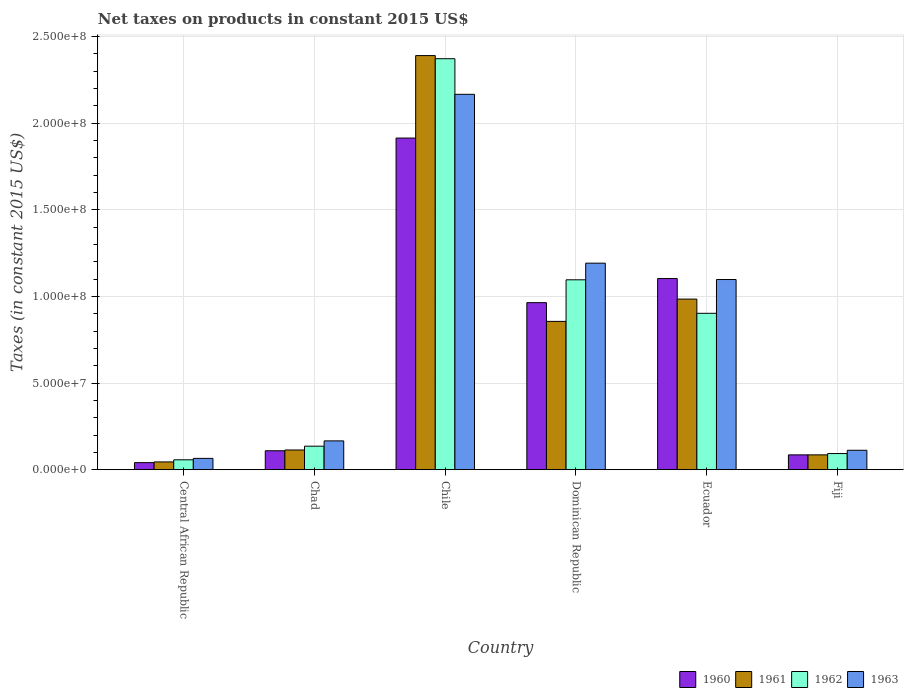Are the number of bars on each tick of the X-axis equal?
Give a very brief answer. Yes. How many bars are there on the 5th tick from the right?
Offer a very short reply. 4. What is the label of the 2nd group of bars from the left?
Provide a succinct answer. Chad. What is the net taxes on products in 1962 in Chad?
Provide a short and direct response. 1.36e+07. Across all countries, what is the maximum net taxes on products in 1963?
Make the answer very short. 2.17e+08. Across all countries, what is the minimum net taxes on products in 1960?
Offer a terse response. 4.08e+06. In which country was the net taxes on products in 1961 minimum?
Your answer should be compact. Central African Republic. What is the total net taxes on products in 1963 in the graph?
Offer a very short reply. 4.80e+08. What is the difference between the net taxes on products in 1962 in Ecuador and that in Fiji?
Provide a succinct answer. 8.09e+07. What is the difference between the net taxes on products in 1961 in Chile and the net taxes on products in 1960 in Fiji?
Your answer should be very brief. 2.30e+08. What is the average net taxes on products in 1961 per country?
Your answer should be very brief. 7.46e+07. What is the difference between the net taxes on products of/in 1960 and net taxes on products of/in 1963 in Chile?
Provide a succinct answer. -2.52e+07. In how many countries, is the net taxes on products in 1963 greater than 20000000 US$?
Ensure brevity in your answer.  3. What is the ratio of the net taxes on products in 1962 in Central African Republic to that in Chile?
Make the answer very short. 0.02. Is the difference between the net taxes on products in 1960 in Chad and Fiji greater than the difference between the net taxes on products in 1963 in Chad and Fiji?
Give a very brief answer. No. What is the difference between the highest and the second highest net taxes on products in 1962?
Offer a terse response. 1.93e+07. What is the difference between the highest and the lowest net taxes on products in 1963?
Offer a very short reply. 2.10e+08. Is the sum of the net taxes on products in 1963 in Dominican Republic and Ecuador greater than the maximum net taxes on products in 1961 across all countries?
Give a very brief answer. No. Are the values on the major ticks of Y-axis written in scientific E-notation?
Give a very brief answer. Yes. Does the graph contain any zero values?
Offer a very short reply. No. What is the title of the graph?
Provide a succinct answer. Net taxes on products in constant 2015 US$. What is the label or title of the Y-axis?
Offer a very short reply. Taxes (in constant 2015 US$). What is the Taxes (in constant 2015 US$) in 1960 in Central African Republic?
Provide a short and direct response. 4.08e+06. What is the Taxes (in constant 2015 US$) of 1961 in Central African Republic?
Make the answer very short. 4.49e+06. What is the Taxes (in constant 2015 US$) in 1962 in Central African Republic?
Your answer should be compact. 5.71e+06. What is the Taxes (in constant 2015 US$) of 1963 in Central African Republic?
Your response must be concise. 6.53e+06. What is the Taxes (in constant 2015 US$) of 1960 in Chad?
Your answer should be very brief. 1.09e+07. What is the Taxes (in constant 2015 US$) of 1961 in Chad?
Ensure brevity in your answer.  1.14e+07. What is the Taxes (in constant 2015 US$) in 1962 in Chad?
Your answer should be very brief. 1.36e+07. What is the Taxes (in constant 2015 US$) in 1963 in Chad?
Provide a succinct answer. 1.66e+07. What is the Taxes (in constant 2015 US$) in 1960 in Chile?
Provide a succinct answer. 1.91e+08. What is the Taxes (in constant 2015 US$) of 1961 in Chile?
Provide a succinct answer. 2.39e+08. What is the Taxes (in constant 2015 US$) in 1962 in Chile?
Make the answer very short. 2.37e+08. What is the Taxes (in constant 2015 US$) of 1963 in Chile?
Provide a short and direct response. 2.17e+08. What is the Taxes (in constant 2015 US$) in 1960 in Dominican Republic?
Provide a short and direct response. 9.64e+07. What is the Taxes (in constant 2015 US$) of 1961 in Dominican Republic?
Your response must be concise. 8.56e+07. What is the Taxes (in constant 2015 US$) of 1962 in Dominican Republic?
Your answer should be very brief. 1.10e+08. What is the Taxes (in constant 2015 US$) of 1963 in Dominican Republic?
Your response must be concise. 1.19e+08. What is the Taxes (in constant 2015 US$) of 1960 in Ecuador?
Provide a short and direct response. 1.10e+08. What is the Taxes (in constant 2015 US$) of 1961 in Ecuador?
Offer a very short reply. 9.85e+07. What is the Taxes (in constant 2015 US$) in 1962 in Ecuador?
Provide a short and direct response. 9.03e+07. What is the Taxes (in constant 2015 US$) of 1963 in Ecuador?
Offer a very short reply. 1.10e+08. What is the Taxes (in constant 2015 US$) in 1960 in Fiji?
Make the answer very short. 8.56e+06. What is the Taxes (in constant 2015 US$) in 1961 in Fiji?
Keep it short and to the point. 8.56e+06. What is the Taxes (in constant 2015 US$) in 1962 in Fiji?
Ensure brevity in your answer.  9.32e+06. What is the Taxes (in constant 2015 US$) of 1963 in Fiji?
Offer a very short reply. 1.12e+07. Across all countries, what is the maximum Taxes (in constant 2015 US$) of 1960?
Offer a terse response. 1.91e+08. Across all countries, what is the maximum Taxes (in constant 2015 US$) of 1961?
Keep it short and to the point. 2.39e+08. Across all countries, what is the maximum Taxes (in constant 2015 US$) in 1962?
Ensure brevity in your answer.  2.37e+08. Across all countries, what is the maximum Taxes (in constant 2015 US$) in 1963?
Provide a succinct answer. 2.17e+08. Across all countries, what is the minimum Taxes (in constant 2015 US$) in 1960?
Give a very brief answer. 4.08e+06. Across all countries, what is the minimum Taxes (in constant 2015 US$) of 1961?
Your response must be concise. 4.49e+06. Across all countries, what is the minimum Taxes (in constant 2015 US$) of 1962?
Your response must be concise. 5.71e+06. Across all countries, what is the minimum Taxes (in constant 2015 US$) of 1963?
Provide a short and direct response. 6.53e+06. What is the total Taxes (in constant 2015 US$) in 1960 in the graph?
Your response must be concise. 4.22e+08. What is the total Taxes (in constant 2015 US$) of 1961 in the graph?
Give a very brief answer. 4.47e+08. What is the total Taxes (in constant 2015 US$) of 1962 in the graph?
Offer a terse response. 4.66e+08. What is the total Taxes (in constant 2015 US$) in 1963 in the graph?
Give a very brief answer. 4.80e+08. What is the difference between the Taxes (in constant 2015 US$) in 1960 in Central African Republic and that in Chad?
Offer a very short reply. -6.86e+06. What is the difference between the Taxes (in constant 2015 US$) of 1961 in Central African Republic and that in Chad?
Make the answer very short. -6.88e+06. What is the difference between the Taxes (in constant 2015 US$) in 1962 in Central African Republic and that in Chad?
Offer a terse response. -7.86e+06. What is the difference between the Taxes (in constant 2015 US$) in 1963 in Central African Republic and that in Chad?
Provide a succinct answer. -1.01e+07. What is the difference between the Taxes (in constant 2015 US$) in 1960 in Central African Republic and that in Chile?
Your response must be concise. -1.87e+08. What is the difference between the Taxes (in constant 2015 US$) in 1961 in Central African Republic and that in Chile?
Provide a succinct answer. -2.35e+08. What is the difference between the Taxes (in constant 2015 US$) of 1962 in Central African Republic and that in Chile?
Keep it short and to the point. -2.31e+08. What is the difference between the Taxes (in constant 2015 US$) of 1963 in Central African Republic and that in Chile?
Ensure brevity in your answer.  -2.10e+08. What is the difference between the Taxes (in constant 2015 US$) of 1960 in Central African Republic and that in Dominican Republic?
Keep it short and to the point. -9.23e+07. What is the difference between the Taxes (in constant 2015 US$) in 1961 in Central African Republic and that in Dominican Republic?
Your response must be concise. -8.11e+07. What is the difference between the Taxes (in constant 2015 US$) in 1962 in Central African Republic and that in Dominican Republic?
Offer a terse response. -1.04e+08. What is the difference between the Taxes (in constant 2015 US$) of 1963 in Central African Republic and that in Dominican Republic?
Your response must be concise. -1.13e+08. What is the difference between the Taxes (in constant 2015 US$) of 1960 in Central African Republic and that in Ecuador?
Offer a terse response. -1.06e+08. What is the difference between the Taxes (in constant 2015 US$) in 1961 in Central African Republic and that in Ecuador?
Ensure brevity in your answer.  -9.40e+07. What is the difference between the Taxes (in constant 2015 US$) in 1962 in Central African Republic and that in Ecuador?
Ensure brevity in your answer.  -8.45e+07. What is the difference between the Taxes (in constant 2015 US$) of 1963 in Central African Republic and that in Ecuador?
Keep it short and to the point. -1.03e+08. What is the difference between the Taxes (in constant 2015 US$) of 1960 in Central African Republic and that in Fiji?
Offer a terse response. -4.49e+06. What is the difference between the Taxes (in constant 2015 US$) in 1961 in Central African Republic and that in Fiji?
Make the answer very short. -4.08e+06. What is the difference between the Taxes (in constant 2015 US$) in 1962 in Central African Republic and that in Fiji?
Ensure brevity in your answer.  -3.61e+06. What is the difference between the Taxes (in constant 2015 US$) of 1963 in Central African Republic and that in Fiji?
Provide a succinct answer. -4.68e+06. What is the difference between the Taxes (in constant 2015 US$) in 1960 in Chad and that in Chile?
Offer a very short reply. -1.80e+08. What is the difference between the Taxes (in constant 2015 US$) in 1961 in Chad and that in Chile?
Your answer should be compact. -2.28e+08. What is the difference between the Taxes (in constant 2015 US$) in 1962 in Chad and that in Chile?
Ensure brevity in your answer.  -2.24e+08. What is the difference between the Taxes (in constant 2015 US$) in 1963 in Chad and that in Chile?
Offer a terse response. -2.00e+08. What is the difference between the Taxes (in constant 2015 US$) of 1960 in Chad and that in Dominican Republic?
Keep it short and to the point. -8.55e+07. What is the difference between the Taxes (in constant 2015 US$) in 1961 in Chad and that in Dominican Republic?
Provide a short and direct response. -7.42e+07. What is the difference between the Taxes (in constant 2015 US$) in 1962 in Chad and that in Dominican Republic?
Offer a terse response. -9.60e+07. What is the difference between the Taxes (in constant 2015 US$) of 1963 in Chad and that in Dominican Republic?
Your response must be concise. -1.03e+08. What is the difference between the Taxes (in constant 2015 US$) of 1960 in Chad and that in Ecuador?
Your response must be concise. -9.94e+07. What is the difference between the Taxes (in constant 2015 US$) in 1961 in Chad and that in Ecuador?
Make the answer very short. -8.71e+07. What is the difference between the Taxes (in constant 2015 US$) of 1962 in Chad and that in Ecuador?
Your answer should be compact. -7.67e+07. What is the difference between the Taxes (in constant 2015 US$) of 1963 in Chad and that in Ecuador?
Provide a short and direct response. -9.31e+07. What is the difference between the Taxes (in constant 2015 US$) of 1960 in Chad and that in Fiji?
Offer a terse response. 2.37e+06. What is the difference between the Taxes (in constant 2015 US$) in 1961 in Chad and that in Fiji?
Your answer should be compact. 2.81e+06. What is the difference between the Taxes (in constant 2015 US$) of 1962 in Chad and that in Fiji?
Offer a very short reply. 4.25e+06. What is the difference between the Taxes (in constant 2015 US$) of 1963 in Chad and that in Fiji?
Provide a short and direct response. 5.43e+06. What is the difference between the Taxes (in constant 2015 US$) of 1960 in Chile and that in Dominican Republic?
Provide a succinct answer. 9.50e+07. What is the difference between the Taxes (in constant 2015 US$) of 1961 in Chile and that in Dominican Republic?
Provide a succinct answer. 1.53e+08. What is the difference between the Taxes (in constant 2015 US$) in 1962 in Chile and that in Dominican Republic?
Offer a very short reply. 1.28e+08. What is the difference between the Taxes (in constant 2015 US$) of 1963 in Chile and that in Dominican Republic?
Your answer should be very brief. 9.74e+07. What is the difference between the Taxes (in constant 2015 US$) of 1960 in Chile and that in Ecuador?
Keep it short and to the point. 8.11e+07. What is the difference between the Taxes (in constant 2015 US$) in 1961 in Chile and that in Ecuador?
Your answer should be very brief. 1.41e+08. What is the difference between the Taxes (in constant 2015 US$) of 1962 in Chile and that in Ecuador?
Provide a succinct answer. 1.47e+08. What is the difference between the Taxes (in constant 2015 US$) in 1963 in Chile and that in Ecuador?
Offer a terse response. 1.07e+08. What is the difference between the Taxes (in constant 2015 US$) in 1960 in Chile and that in Fiji?
Ensure brevity in your answer.  1.83e+08. What is the difference between the Taxes (in constant 2015 US$) of 1961 in Chile and that in Fiji?
Provide a short and direct response. 2.30e+08. What is the difference between the Taxes (in constant 2015 US$) in 1962 in Chile and that in Fiji?
Ensure brevity in your answer.  2.28e+08. What is the difference between the Taxes (in constant 2015 US$) of 1963 in Chile and that in Fiji?
Keep it short and to the point. 2.05e+08. What is the difference between the Taxes (in constant 2015 US$) in 1960 in Dominican Republic and that in Ecuador?
Your answer should be very brief. -1.39e+07. What is the difference between the Taxes (in constant 2015 US$) of 1961 in Dominican Republic and that in Ecuador?
Your answer should be very brief. -1.29e+07. What is the difference between the Taxes (in constant 2015 US$) in 1962 in Dominican Republic and that in Ecuador?
Your answer should be compact. 1.93e+07. What is the difference between the Taxes (in constant 2015 US$) of 1963 in Dominican Republic and that in Ecuador?
Provide a short and direct response. 9.44e+06. What is the difference between the Taxes (in constant 2015 US$) of 1960 in Dominican Republic and that in Fiji?
Provide a succinct answer. 8.78e+07. What is the difference between the Taxes (in constant 2015 US$) of 1961 in Dominican Republic and that in Fiji?
Provide a short and direct response. 7.70e+07. What is the difference between the Taxes (in constant 2015 US$) in 1962 in Dominican Republic and that in Fiji?
Provide a succinct answer. 1.00e+08. What is the difference between the Taxes (in constant 2015 US$) of 1963 in Dominican Republic and that in Fiji?
Provide a short and direct response. 1.08e+08. What is the difference between the Taxes (in constant 2015 US$) in 1960 in Ecuador and that in Fiji?
Provide a succinct answer. 1.02e+08. What is the difference between the Taxes (in constant 2015 US$) in 1961 in Ecuador and that in Fiji?
Make the answer very short. 8.99e+07. What is the difference between the Taxes (in constant 2015 US$) of 1962 in Ecuador and that in Fiji?
Provide a succinct answer. 8.09e+07. What is the difference between the Taxes (in constant 2015 US$) of 1963 in Ecuador and that in Fiji?
Keep it short and to the point. 9.86e+07. What is the difference between the Taxes (in constant 2015 US$) in 1960 in Central African Republic and the Taxes (in constant 2015 US$) in 1961 in Chad?
Make the answer very short. -7.29e+06. What is the difference between the Taxes (in constant 2015 US$) in 1960 in Central African Republic and the Taxes (in constant 2015 US$) in 1962 in Chad?
Provide a short and direct response. -9.49e+06. What is the difference between the Taxes (in constant 2015 US$) of 1960 in Central African Republic and the Taxes (in constant 2015 US$) of 1963 in Chad?
Your answer should be compact. -1.26e+07. What is the difference between the Taxes (in constant 2015 US$) of 1961 in Central African Republic and the Taxes (in constant 2015 US$) of 1962 in Chad?
Provide a succinct answer. -9.08e+06. What is the difference between the Taxes (in constant 2015 US$) in 1961 in Central African Republic and the Taxes (in constant 2015 US$) in 1963 in Chad?
Your answer should be very brief. -1.21e+07. What is the difference between the Taxes (in constant 2015 US$) in 1962 in Central African Republic and the Taxes (in constant 2015 US$) in 1963 in Chad?
Offer a terse response. -1.09e+07. What is the difference between the Taxes (in constant 2015 US$) in 1960 in Central African Republic and the Taxes (in constant 2015 US$) in 1961 in Chile?
Give a very brief answer. -2.35e+08. What is the difference between the Taxes (in constant 2015 US$) in 1960 in Central African Republic and the Taxes (in constant 2015 US$) in 1962 in Chile?
Ensure brevity in your answer.  -2.33e+08. What is the difference between the Taxes (in constant 2015 US$) of 1960 in Central African Republic and the Taxes (in constant 2015 US$) of 1963 in Chile?
Your answer should be very brief. -2.13e+08. What is the difference between the Taxes (in constant 2015 US$) of 1961 in Central African Republic and the Taxes (in constant 2015 US$) of 1962 in Chile?
Provide a short and direct response. -2.33e+08. What is the difference between the Taxes (in constant 2015 US$) in 1961 in Central African Republic and the Taxes (in constant 2015 US$) in 1963 in Chile?
Offer a very short reply. -2.12e+08. What is the difference between the Taxes (in constant 2015 US$) of 1962 in Central African Republic and the Taxes (in constant 2015 US$) of 1963 in Chile?
Ensure brevity in your answer.  -2.11e+08. What is the difference between the Taxes (in constant 2015 US$) of 1960 in Central African Republic and the Taxes (in constant 2015 US$) of 1961 in Dominican Republic?
Provide a short and direct response. -8.15e+07. What is the difference between the Taxes (in constant 2015 US$) in 1960 in Central African Republic and the Taxes (in constant 2015 US$) in 1962 in Dominican Republic?
Ensure brevity in your answer.  -1.06e+08. What is the difference between the Taxes (in constant 2015 US$) of 1960 in Central African Republic and the Taxes (in constant 2015 US$) of 1963 in Dominican Republic?
Provide a short and direct response. -1.15e+08. What is the difference between the Taxes (in constant 2015 US$) of 1961 in Central African Republic and the Taxes (in constant 2015 US$) of 1962 in Dominican Republic?
Provide a short and direct response. -1.05e+08. What is the difference between the Taxes (in constant 2015 US$) in 1961 in Central African Republic and the Taxes (in constant 2015 US$) in 1963 in Dominican Republic?
Offer a terse response. -1.15e+08. What is the difference between the Taxes (in constant 2015 US$) in 1962 in Central African Republic and the Taxes (in constant 2015 US$) in 1963 in Dominican Republic?
Your response must be concise. -1.13e+08. What is the difference between the Taxes (in constant 2015 US$) in 1960 in Central African Republic and the Taxes (in constant 2015 US$) in 1961 in Ecuador?
Provide a short and direct response. -9.44e+07. What is the difference between the Taxes (in constant 2015 US$) of 1960 in Central African Republic and the Taxes (in constant 2015 US$) of 1962 in Ecuador?
Give a very brief answer. -8.62e+07. What is the difference between the Taxes (in constant 2015 US$) of 1960 in Central African Republic and the Taxes (in constant 2015 US$) of 1963 in Ecuador?
Ensure brevity in your answer.  -1.06e+08. What is the difference between the Taxes (in constant 2015 US$) in 1961 in Central African Republic and the Taxes (in constant 2015 US$) in 1962 in Ecuador?
Keep it short and to the point. -8.58e+07. What is the difference between the Taxes (in constant 2015 US$) in 1961 in Central African Republic and the Taxes (in constant 2015 US$) in 1963 in Ecuador?
Offer a very short reply. -1.05e+08. What is the difference between the Taxes (in constant 2015 US$) in 1962 in Central African Republic and the Taxes (in constant 2015 US$) in 1963 in Ecuador?
Your answer should be compact. -1.04e+08. What is the difference between the Taxes (in constant 2015 US$) in 1960 in Central African Republic and the Taxes (in constant 2015 US$) in 1961 in Fiji?
Provide a succinct answer. -4.49e+06. What is the difference between the Taxes (in constant 2015 US$) of 1960 in Central African Republic and the Taxes (in constant 2015 US$) of 1962 in Fiji?
Offer a terse response. -5.24e+06. What is the difference between the Taxes (in constant 2015 US$) of 1960 in Central African Republic and the Taxes (in constant 2015 US$) of 1963 in Fiji?
Ensure brevity in your answer.  -7.13e+06. What is the difference between the Taxes (in constant 2015 US$) of 1961 in Central African Republic and the Taxes (in constant 2015 US$) of 1962 in Fiji?
Your answer should be very brief. -4.83e+06. What is the difference between the Taxes (in constant 2015 US$) of 1961 in Central African Republic and the Taxes (in constant 2015 US$) of 1963 in Fiji?
Your response must be concise. -6.72e+06. What is the difference between the Taxes (in constant 2015 US$) in 1962 in Central African Republic and the Taxes (in constant 2015 US$) in 1963 in Fiji?
Keep it short and to the point. -5.49e+06. What is the difference between the Taxes (in constant 2015 US$) of 1960 in Chad and the Taxes (in constant 2015 US$) of 1961 in Chile?
Make the answer very short. -2.28e+08. What is the difference between the Taxes (in constant 2015 US$) of 1960 in Chad and the Taxes (in constant 2015 US$) of 1962 in Chile?
Offer a very short reply. -2.26e+08. What is the difference between the Taxes (in constant 2015 US$) of 1960 in Chad and the Taxes (in constant 2015 US$) of 1963 in Chile?
Give a very brief answer. -2.06e+08. What is the difference between the Taxes (in constant 2015 US$) in 1961 in Chad and the Taxes (in constant 2015 US$) in 1962 in Chile?
Make the answer very short. -2.26e+08. What is the difference between the Taxes (in constant 2015 US$) in 1961 in Chad and the Taxes (in constant 2015 US$) in 1963 in Chile?
Provide a succinct answer. -2.05e+08. What is the difference between the Taxes (in constant 2015 US$) in 1962 in Chad and the Taxes (in constant 2015 US$) in 1963 in Chile?
Provide a short and direct response. -2.03e+08. What is the difference between the Taxes (in constant 2015 US$) of 1960 in Chad and the Taxes (in constant 2015 US$) of 1961 in Dominican Republic?
Ensure brevity in your answer.  -7.47e+07. What is the difference between the Taxes (in constant 2015 US$) in 1960 in Chad and the Taxes (in constant 2015 US$) in 1962 in Dominican Republic?
Offer a very short reply. -9.87e+07. What is the difference between the Taxes (in constant 2015 US$) of 1960 in Chad and the Taxes (in constant 2015 US$) of 1963 in Dominican Republic?
Your answer should be compact. -1.08e+08. What is the difference between the Taxes (in constant 2015 US$) of 1961 in Chad and the Taxes (in constant 2015 US$) of 1962 in Dominican Republic?
Ensure brevity in your answer.  -9.82e+07. What is the difference between the Taxes (in constant 2015 US$) in 1961 in Chad and the Taxes (in constant 2015 US$) in 1963 in Dominican Republic?
Provide a short and direct response. -1.08e+08. What is the difference between the Taxes (in constant 2015 US$) of 1962 in Chad and the Taxes (in constant 2015 US$) of 1963 in Dominican Republic?
Provide a succinct answer. -1.06e+08. What is the difference between the Taxes (in constant 2015 US$) of 1960 in Chad and the Taxes (in constant 2015 US$) of 1961 in Ecuador?
Ensure brevity in your answer.  -8.75e+07. What is the difference between the Taxes (in constant 2015 US$) of 1960 in Chad and the Taxes (in constant 2015 US$) of 1962 in Ecuador?
Keep it short and to the point. -7.93e+07. What is the difference between the Taxes (in constant 2015 US$) in 1960 in Chad and the Taxes (in constant 2015 US$) in 1963 in Ecuador?
Ensure brevity in your answer.  -9.88e+07. What is the difference between the Taxes (in constant 2015 US$) in 1961 in Chad and the Taxes (in constant 2015 US$) in 1962 in Ecuador?
Provide a succinct answer. -7.89e+07. What is the difference between the Taxes (in constant 2015 US$) of 1961 in Chad and the Taxes (in constant 2015 US$) of 1963 in Ecuador?
Ensure brevity in your answer.  -9.84e+07. What is the difference between the Taxes (in constant 2015 US$) in 1962 in Chad and the Taxes (in constant 2015 US$) in 1963 in Ecuador?
Provide a succinct answer. -9.62e+07. What is the difference between the Taxes (in constant 2015 US$) of 1960 in Chad and the Taxes (in constant 2015 US$) of 1961 in Fiji?
Make the answer very short. 2.37e+06. What is the difference between the Taxes (in constant 2015 US$) in 1960 in Chad and the Taxes (in constant 2015 US$) in 1962 in Fiji?
Provide a short and direct response. 1.62e+06. What is the difference between the Taxes (in constant 2015 US$) of 1960 in Chad and the Taxes (in constant 2015 US$) of 1963 in Fiji?
Offer a very short reply. -2.73e+05. What is the difference between the Taxes (in constant 2015 US$) of 1961 in Chad and the Taxes (in constant 2015 US$) of 1962 in Fiji?
Your answer should be very brief. 2.05e+06. What is the difference between the Taxes (in constant 2015 US$) of 1961 in Chad and the Taxes (in constant 2015 US$) of 1963 in Fiji?
Provide a short and direct response. 1.61e+05. What is the difference between the Taxes (in constant 2015 US$) of 1962 in Chad and the Taxes (in constant 2015 US$) of 1963 in Fiji?
Provide a succinct answer. 2.36e+06. What is the difference between the Taxes (in constant 2015 US$) in 1960 in Chile and the Taxes (in constant 2015 US$) in 1961 in Dominican Republic?
Your answer should be very brief. 1.06e+08. What is the difference between the Taxes (in constant 2015 US$) of 1960 in Chile and the Taxes (in constant 2015 US$) of 1962 in Dominican Republic?
Keep it short and to the point. 8.18e+07. What is the difference between the Taxes (in constant 2015 US$) of 1960 in Chile and the Taxes (in constant 2015 US$) of 1963 in Dominican Republic?
Give a very brief answer. 7.22e+07. What is the difference between the Taxes (in constant 2015 US$) in 1961 in Chile and the Taxes (in constant 2015 US$) in 1962 in Dominican Republic?
Ensure brevity in your answer.  1.29e+08. What is the difference between the Taxes (in constant 2015 US$) in 1961 in Chile and the Taxes (in constant 2015 US$) in 1963 in Dominican Republic?
Provide a short and direct response. 1.20e+08. What is the difference between the Taxes (in constant 2015 US$) in 1962 in Chile and the Taxes (in constant 2015 US$) in 1963 in Dominican Republic?
Ensure brevity in your answer.  1.18e+08. What is the difference between the Taxes (in constant 2015 US$) in 1960 in Chile and the Taxes (in constant 2015 US$) in 1961 in Ecuador?
Make the answer very short. 9.29e+07. What is the difference between the Taxes (in constant 2015 US$) in 1960 in Chile and the Taxes (in constant 2015 US$) in 1962 in Ecuador?
Your answer should be compact. 1.01e+08. What is the difference between the Taxes (in constant 2015 US$) of 1960 in Chile and the Taxes (in constant 2015 US$) of 1963 in Ecuador?
Provide a succinct answer. 8.16e+07. What is the difference between the Taxes (in constant 2015 US$) in 1961 in Chile and the Taxes (in constant 2015 US$) in 1962 in Ecuador?
Provide a short and direct response. 1.49e+08. What is the difference between the Taxes (in constant 2015 US$) of 1961 in Chile and the Taxes (in constant 2015 US$) of 1963 in Ecuador?
Your answer should be very brief. 1.29e+08. What is the difference between the Taxes (in constant 2015 US$) in 1962 in Chile and the Taxes (in constant 2015 US$) in 1963 in Ecuador?
Offer a terse response. 1.27e+08. What is the difference between the Taxes (in constant 2015 US$) in 1960 in Chile and the Taxes (in constant 2015 US$) in 1961 in Fiji?
Ensure brevity in your answer.  1.83e+08. What is the difference between the Taxes (in constant 2015 US$) of 1960 in Chile and the Taxes (in constant 2015 US$) of 1962 in Fiji?
Your response must be concise. 1.82e+08. What is the difference between the Taxes (in constant 2015 US$) of 1960 in Chile and the Taxes (in constant 2015 US$) of 1963 in Fiji?
Your answer should be compact. 1.80e+08. What is the difference between the Taxes (in constant 2015 US$) of 1961 in Chile and the Taxes (in constant 2015 US$) of 1962 in Fiji?
Make the answer very short. 2.30e+08. What is the difference between the Taxes (in constant 2015 US$) in 1961 in Chile and the Taxes (in constant 2015 US$) in 1963 in Fiji?
Your answer should be compact. 2.28e+08. What is the difference between the Taxes (in constant 2015 US$) of 1962 in Chile and the Taxes (in constant 2015 US$) of 1963 in Fiji?
Give a very brief answer. 2.26e+08. What is the difference between the Taxes (in constant 2015 US$) of 1960 in Dominican Republic and the Taxes (in constant 2015 US$) of 1961 in Ecuador?
Your answer should be compact. -2.07e+06. What is the difference between the Taxes (in constant 2015 US$) of 1960 in Dominican Republic and the Taxes (in constant 2015 US$) of 1962 in Ecuador?
Give a very brief answer. 6.14e+06. What is the difference between the Taxes (in constant 2015 US$) of 1960 in Dominican Republic and the Taxes (in constant 2015 US$) of 1963 in Ecuador?
Ensure brevity in your answer.  -1.34e+07. What is the difference between the Taxes (in constant 2015 US$) in 1961 in Dominican Republic and the Taxes (in constant 2015 US$) in 1962 in Ecuador?
Offer a very short reply. -4.66e+06. What is the difference between the Taxes (in constant 2015 US$) of 1961 in Dominican Republic and the Taxes (in constant 2015 US$) of 1963 in Ecuador?
Provide a short and direct response. -2.42e+07. What is the difference between the Taxes (in constant 2015 US$) of 1962 in Dominican Republic and the Taxes (in constant 2015 US$) of 1963 in Ecuador?
Offer a very short reply. -1.64e+05. What is the difference between the Taxes (in constant 2015 US$) in 1960 in Dominican Republic and the Taxes (in constant 2015 US$) in 1961 in Fiji?
Your answer should be compact. 8.78e+07. What is the difference between the Taxes (in constant 2015 US$) in 1960 in Dominican Republic and the Taxes (in constant 2015 US$) in 1962 in Fiji?
Provide a short and direct response. 8.71e+07. What is the difference between the Taxes (in constant 2015 US$) of 1960 in Dominican Republic and the Taxes (in constant 2015 US$) of 1963 in Fiji?
Provide a short and direct response. 8.52e+07. What is the difference between the Taxes (in constant 2015 US$) of 1961 in Dominican Republic and the Taxes (in constant 2015 US$) of 1962 in Fiji?
Your answer should be compact. 7.63e+07. What is the difference between the Taxes (in constant 2015 US$) of 1961 in Dominican Republic and the Taxes (in constant 2015 US$) of 1963 in Fiji?
Your answer should be compact. 7.44e+07. What is the difference between the Taxes (in constant 2015 US$) of 1962 in Dominican Republic and the Taxes (in constant 2015 US$) of 1963 in Fiji?
Make the answer very short. 9.84e+07. What is the difference between the Taxes (in constant 2015 US$) of 1960 in Ecuador and the Taxes (in constant 2015 US$) of 1961 in Fiji?
Offer a very short reply. 1.02e+08. What is the difference between the Taxes (in constant 2015 US$) in 1960 in Ecuador and the Taxes (in constant 2015 US$) in 1962 in Fiji?
Make the answer very short. 1.01e+08. What is the difference between the Taxes (in constant 2015 US$) in 1960 in Ecuador and the Taxes (in constant 2015 US$) in 1963 in Fiji?
Your answer should be very brief. 9.91e+07. What is the difference between the Taxes (in constant 2015 US$) of 1961 in Ecuador and the Taxes (in constant 2015 US$) of 1962 in Fiji?
Offer a terse response. 8.91e+07. What is the difference between the Taxes (in constant 2015 US$) of 1961 in Ecuador and the Taxes (in constant 2015 US$) of 1963 in Fiji?
Keep it short and to the point. 8.73e+07. What is the difference between the Taxes (in constant 2015 US$) of 1962 in Ecuador and the Taxes (in constant 2015 US$) of 1963 in Fiji?
Offer a very short reply. 7.91e+07. What is the average Taxes (in constant 2015 US$) of 1960 per country?
Keep it short and to the point. 7.03e+07. What is the average Taxes (in constant 2015 US$) in 1961 per country?
Offer a very short reply. 7.46e+07. What is the average Taxes (in constant 2015 US$) in 1962 per country?
Provide a succinct answer. 7.76e+07. What is the average Taxes (in constant 2015 US$) in 1963 per country?
Your response must be concise. 8.00e+07. What is the difference between the Taxes (in constant 2015 US$) of 1960 and Taxes (in constant 2015 US$) of 1961 in Central African Republic?
Offer a terse response. -4.07e+05. What is the difference between the Taxes (in constant 2015 US$) in 1960 and Taxes (in constant 2015 US$) in 1962 in Central African Republic?
Your answer should be compact. -1.64e+06. What is the difference between the Taxes (in constant 2015 US$) in 1960 and Taxes (in constant 2015 US$) in 1963 in Central African Republic?
Your response must be concise. -2.45e+06. What is the difference between the Taxes (in constant 2015 US$) of 1961 and Taxes (in constant 2015 US$) of 1962 in Central African Republic?
Your answer should be compact. -1.23e+06. What is the difference between the Taxes (in constant 2015 US$) of 1961 and Taxes (in constant 2015 US$) of 1963 in Central African Republic?
Offer a terse response. -2.05e+06. What is the difference between the Taxes (in constant 2015 US$) of 1962 and Taxes (in constant 2015 US$) of 1963 in Central African Republic?
Offer a very short reply. -8.16e+05. What is the difference between the Taxes (in constant 2015 US$) in 1960 and Taxes (in constant 2015 US$) in 1961 in Chad?
Your answer should be compact. -4.34e+05. What is the difference between the Taxes (in constant 2015 US$) in 1960 and Taxes (in constant 2015 US$) in 1962 in Chad?
Your answer should be compact. -2.63e+06. What is the difference between the Taxes (in constant 2015 US$) of 1960 and Taxes (in constant 2015 US$) of 1963 in Chad?
Your answer should be compact. -5.70e+06. What is the difference between the Taxes (in constant 2015 US$) in 1961 and Taxes (in constant 2015 US$) in 1962 in Chad?
Offer a terse response. -2.20e+06. What is the difference between the Taxes (in constant 2015 US$) of 1961 and Taxes (in constant 2015 US$) of 1963 in Chad?
Your answer should be very brief. -5.26e+06. What is the difference between the Taxes (in constant 2015 US$) in 1962 and Taxes (in constant 2015 US$) in 1963 in Chad?
Ensure brevity in your answer.  -3.06e+06. What is the difference between the Taxes (in constant 2015 US$) in 1960 and Taxes (in constant 2015 US$) in 1961 in Chile?
Your answer should be very brief. -4.76e+07. What is the difference between the Taxes (in constant 2015 US$) of 1960 and Taxes (in constant 2015 US$) of 1962 in Chile?
Ensure brevity in your answer.  -4.58e+07. What is the difference between the Taxes (in constant 2015 US$) in 1960 and Taxes (in constant 2015 US$) in 1963 in Chile?
Keep it short and to the point. -2.52e+07. What is the difference between the Taxes (in constant 2015 US$) of 1961 and Taxes (in constant 2015 US$) of 1962 in Chile?
Ensure brevity in your answer.  1.81e+06. What is the difference between the Taxes (in constant 2015 US$) of 1961 and Taxes (in constant 2015 US$) of 1963 in Chile?
Provide a short and direct response. 2.24e+07. What is the difference between the Taxes (in constant 2015 US$) in 1962 and Taxes (in constant 2015 US$) in 1963 in Chile?
Your answer should be compact. 2.06e+07. What is the difference between the Taxes (in constant 2015 US$) of 1960 and Taxes (in constant 2015 US$) of 1961 in Dominican Republic?
Your answer should be compact. 1.08e+07. What is the difference between the Taxes (in constant 2015 US$) of 1960 and Taxes (in constant 2015 US$) of 1962 in Dominican Republic?
Ensure brevity in your answer.  -1.32e+07. What is the difference between the Taxes (in constant 2015 US$) in 1960 and Taxes (in constant 2015 US$) in 1963 in Dominican Republic?
Ensure brevity in your answer.  -2.28e+07. What is the difference between the Taxes (in constant 2015 US$) of 1961 and Taxes (in constant 2015 US$) of 1962 in Dominican Republic?
Your answer should be very brief. -2.40e+07. What is the difference between the Taxes (in constant 2015 US$) in 1961 and Taxes (in constant 2015 US$) in 1963 in Dominican Republic?
Ensure brevity in your answer.  -3.36e+07. What is the difference between the Taxes (in constant 2015 US$) of 1962 and Taxes (in constant 2015 US$) of 1963 in Dominican Republic?
Provide a succinct answer. -9.60e+06. What is the difference between the Taxes (in constant 2015 US$) of 1960 and Taxes (in constant 2015 US$) of 1961 in Ecuador?
Provide a succinct answer. 1.19e+07. What is the difference between the Taxes (in constant 2015 US$) in 1960 and Taxes (in constant 2015 US$) in 1962 in Ecuador?
Keep it short and to the point. 2.01e+07. What is the difference between the Taxes (in constant 2015 US$) of 1960 and Taxes (in constant 2015 US$) of 1963 in Ecuador?
Give a very brief answer. 5.57e+05. What is the difference between the Taxes (in constant 2015 US$) of 1961 and Taxes (in constant 2015 US$) of 1962 in Ecuador?
Provide a succinct answer. 8.21e+06. What is the difference between the Taxes (in constant 2015 US$) in 1961 and Taxes (in constant 2015 US$) in 1963 in Ecuador?
Provide a succinct answer. -1.13e+07. What is the difference between the Taxes (in constant 2015 US$) in 1962 and Taxes (in constant 2015 US$) in 1963 in Ecuador?
Your answer should be compact. -1.95e+07. What is the difference between the Taxes (in constant 2015 US$) of 1960 and Taxes (in constant 2015 US$) of 1962 in Fiji?
Provide a short and direct response. -7.56e+05. What is the difference between the Taxes (in constant 2015 US$) in 1960 and Taxes (in constant 2015 US$) in 1963 in Fiji?
Your answer should be compact. -2.64e+06. What is the difference between the Taxes (in constant 2015 US$) of 1961 and Taxes (in constant 2015 US$) of 1962 in Fiji?
Make the answer very short. -7.56e+05. What is the difference between the Taxes (in constant 2015 US$) of 1961 and Taxes (in constant 2015 US$) of 1963 in Fiji?
Your answer should be compact. -2.64e+06. What is the difference between the Taxes (in constant 2015 US$) in 1962 and Taxes (in constant 2015 US$) in 1963 in Fiji?
Your response must be concise. -1.89e+06. What is the ratio of the Taxes (in constant 2015 US$) in 1960 in Central African Republic to that in Chad?
Offer a very short reply. 0.37. What is the ratio of the Taxes (in constant 2015 US$) in 1961 in Central African Republic to that in Chad?
Provide a succinct answer. 0.39. What is the ratio of the Taxes (in constant 2015 US$) of 1962 in Central African Republic to that in Chad?
Your answer should be compact. 0.42. What is the ratio of the Taxes (in constant 2015 US$) of 1963 in Central African Republic to that in Chad?
Make the answer very short. 0.39. What is the ratio of the Taxes (in constant 2015 US$) in 1960 in Central African Republic to that in Chile?
Ensure brevity in your answer.  0.02. What is the ratio of the Taxes (in constant 2015 US$) of 1961 in Central African Republic to that in Chile?
Your answer should be compact. 0.02. What is the ratio of the Taxes (in constant 2015 US$) of 1962 in Central African Republic to that in Chile?
Offer a terse response. 0.02. What is the ratio of the Taxes (in constant 2015 US$) in 1963 in Central African Republic to that in Chile?
Keep it short and to the point. 0.03. What is the ratio of the Taxes (in constant 2015 US$) of 1960 in Central African Republic to that in Dominican Republic?
Provide a short and direct response. 0.04. What is the ratio of the Taxes (in constant 2015 US$) of 1961 in Central African Republic to that in Dominican Republic?
Your response must be concise. 0.05. What is the ratio of the Taxes (in constant 2015 US$) of 1962 in Central African Republic to that in Dominican Republic?
Offer a terse response. 0.05. What is the ratio of the Taxes (in constant 2015 US$) of 1963 in Central African Republic to that in Dominican Republic?
Your answer should be very brief. 0.05. What is the ratio of the Taxes (in constant 2015 US$) of 1960 in Central African Republic to that in Ecuador?
Give a very brief answer. 0.04. What is the ratio of the Taxes (in constant 2015 US$) in 1961 in Central African Republic to that in Ecuador?
Give a very brief answer. 0.05. What is the ratio of the Taxes (in constant 2015 US$) in 1962 in Central African Republic to that in Ecuador?
Offer a terse response. 0.06. What is the ratio of the Taxes (in constant 2015 US$) in 1963 in Central African Republic to that in Ecuador?
Keep it short and to the point. 0.06. What is the ratio of the Taxes (in constant 2015 US$) of 1960 in Central African Republic to that in Fiji?
Your answer should be compact. 0.48. What is the ratio of the Taxes (in constant 2015 US$) in 1961 in Central African Republic to that in Fiji?
Provide a short and direct response. 0.52. What is the ratio of the Taxes (in constant 2015 US$) in 1962 in Central African Republic to that in Fiji?
Offer a terse response. 0.61. What is the ratio of the Taxes (in constant 2015 US$) of 1963 in Central African Republic to that in Fiji?
Keep it short and to the point. 0.58. What is the ratio of the Taxes (in constant 2015 US$) in 1960 in Chad to that in Chile?
Ensure brevity in your answer.  0.06. What is the ratio of the Taxes (in constant 2015 US$) in 1961 in Chad to that in Chile?
Your answer should be very brief. 0.05. What is the ratio of the Taxes (in constant 2015 US$) in 1962 in Chad to that in Chile?
Your answer should be very brief. 0.06. What is the ratio of the Taxes (in constant 2015 US$) in 1963 in Chad to that in Chile?
Offer a very short reply. 0.08. What is the ratio of the Taxes (in constant 2015 US$) of 1960 in Chad to that in Dominican Republic?
Provide a short and direct response. 0.11. What is the ratio of the Taxes (in constant 2015 US$) of 1961 in Chad to that in Dominican Republic?
Give a very brief answer. 0.13. What is the ratio of the Taxes (in constant 2015 US$) in 1962 in Chad to that in Dominican Republic?
Give a very brief answer. 0.12. What is the ratio of the Taxes (in constant 2015 US$) of 1963 in Chad to that in Dominican Republic?
Provide a succinct answer. 0.14. What is the ratio of the Taxes (in constant 2015 US$) in 1960 in Chad to that in Ecuador?
Offer a very short reply. 0.1. What is the ratio of the Taxes (in constant 2015 US$) in 1961 in Chad to that in Ecuador?
Your answer should be compact. 0.12. What is the ratio of the Taxes (in constant 2015 US$) in 1962 in Chad to that in Ecuador?
Provide a short and direct response. 0.15. What is the ratio of the Taxes (in constant 2015 US$) in 1963 in Chad to that in Ecuador?
Provide a succinct answer. 0.15. What is the ratio of the Taxes (in constant 2015 US$) of 1960 in Chad to that in Fiji?
Offer a terse response. 1.28. What is the ratio of the Taxes (in constant 2015 US$) in 1961 in Chad to that in Fiji?
Your response must be concise. 1.33. What is the ratio of the Taxes (in constant 2015 US$) of 1962 in Chad to that in Fiji?
Make the answer very short. 1.46. What is the ratio of the Taxes (in constant 2015 US$) of 1963 in Chad to that in Fiji?
Give a very brief answer. 1.48. What is the ratio of the Taxes (in constant 2015 US$) in 1960 in Chile to that in Dominican Republic?
Provide a short and direct response. 1.99. What is the ratio of the Taxes (in constant 2015 US$) of 1961 in Chile to that in Dominican Republic?
Your response must be concise. 2.79. What is the ratio of the Taxes (in constant 2015 US$) in 1962 in Chile to that in Dominican Republic?
Keep it short and to the point. 2.16. What is the ratio of the Taxes (in constant 2015 US$) of 1963 in Chile to that in Dominican Republic?
Provide a succinct answer. 1.82. What is the ratio of the Taxes (in constant 2015 US$) of 1960 in Chile to that in Ecuador?
Make the answer very short. 1.74. What is the ratio of the Taxes (in constant 2015 US$) of 1961 in Chile to that in Ecuador?
Make the answer very short. 2.43. What is the ratio of the Taxes (in constant 2015 US$) in 1962 in Chile to that in Ecuador?
Offer a very short reply. 2.63. What is the ratio of the Taxes (in constant 2015 US$) of 1963 in Chile to that in Ecuador?
Offer a terse response. 1.97. What is the ratio of the Taxes (in constant 2015 US$) of 1960 in Chile to that in Fiji?
Your response must be concise. 22.35. What is the ratio of the Taxes (in constant 2015 US$) in 1961 in Chile to that in Fiji?
Give a very brief answer. 27.91. What is the ratio of the Taxes (in constant 2015 US$) of 1962 in Chile to that in Fiji?
Make the answer very short. 25.45. What is the ratio of the Taxes (in constant 2015 US$) in 1963 in Chile to that in Fiji?
Provide a short and direct response. 19.33. What is the ratio of the Taxes (in constant 2015 US$) of 1960 in Dominican Republic to that in Ecuador?
Offer a very short reply. 0.87. What is the ratio of the Taxes (in constant 2015 US$) of 1961 in Dominican Republic to that in Ecuador?
Provide a short and direct response. 0.87. What is the ratio of the Taxes (in constant 2015 US$) in 1962 in Dominican Republic to that in Ecuador?
Your answer should be compact. 1.21. What is the ratio of the Taxes (in constant 2015 US$) in 1963 in Dominican Republic to that in Ecuador?
Offer a terse response. 1.09. What is the ratio of the Taxes (in constant 2015 US$) of 1960 in Dominican Republic to that in Fiji?
Provide a short and direct response. 11.26. What is the ratio of the Taxes (in constant 2015 US$) in 1961 in Dominican Republic to that in Fiji?
Make the answer very short. 10. What is the ratio of the Taxes (in constant 2015 US$) in 1962 in Dominican Republic to that in Fiji?
Make the answer very short. 11.76. What is the ratio of the Taxes (in constant 2015 US$) of 1963 in Dominican Republic to that in Fiji?
Make the answer very short. 10.63. What is the ratio of the Taxes (in constant 2015 US$) of 1960 in Ecuador to that in Fiji?
Offer a terse response. 12.88. What is the ratio of the Taxes (in constant 2015 US$) in 1961 in Ecuador to that in Fiji?
Provide a short and direct response. 11.5. What is the ratio of the Taxes (in constant 2015 US$) in 1962 in Ecuador to that in Fiji?
Your answer should be compact. 9.69. What is the ratio of the Taxes (in constant 2015 US$) in 1963 in Ecuador to that in Fiji?
Make the answer very short. 9.79. What is the difference between the highest and the second highest Taxes (in constant 2015 US$) of 1960?
Offer a terse response. 8.11e+07. What is the difference between the highest and the second highest Taxes (in constant 2015 US$) of 1961?
Your answer should be very brief. 1.41e+08. What is the difference between the highest and the second highest Taxes (in constant 2015 US$) in 1962?
Your answer should be compact. 1.28e+08. What is the difference between the highest and the second highest Taxes (in constant 2015 US$) in 1963?
Make the answer very short. 9.74e+07. What is the difference between the highest and the lowest Taxes (in constant 2015 US$) of 1960?
Your answer should be compact. 1.87e+08. What is the difference between the highest and the lowest Taxes (in constant 2015 US$) in 1961?
Ensure brevity in your answer.  2.35e+08. What is the difference between the highest and the lowest Taxes (in constant 2015 US$) in 1962?
Offer a terse response. 2.31e+08. What is the difference between the highest and the lowest Taxes (in constant 2015 US$) of 1963?
Your response must be concise. 2.10e+08. 